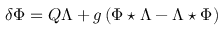<formula> <loc_0><loc_0><loc_500><loc_500>\delta \Phi = Q \Lambda + g \left ( \Phi ^ { * } \Lambda - \Lambda ^ { * } \Phi \right )</formula> 